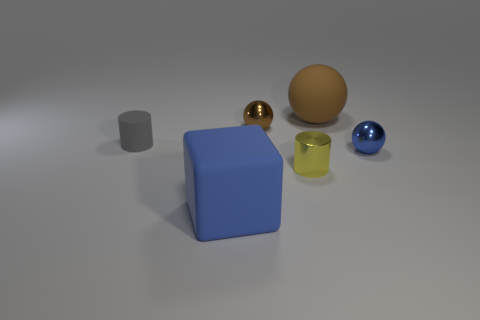Add 4 small blue metal objects. How many objects exist? 10 Subtract all cubes. How many objects are left? 5 Add 1 cyan objects. How many cyan objects exist? 1 Subtract 0 brown cylinders. How many objects are left? 6 Subtract all brown metal things. Subtract all small blue metal balls. How many objects are left? 4 Add 3 small brown shiny balls. How many small brown shiny balls are left? 4 